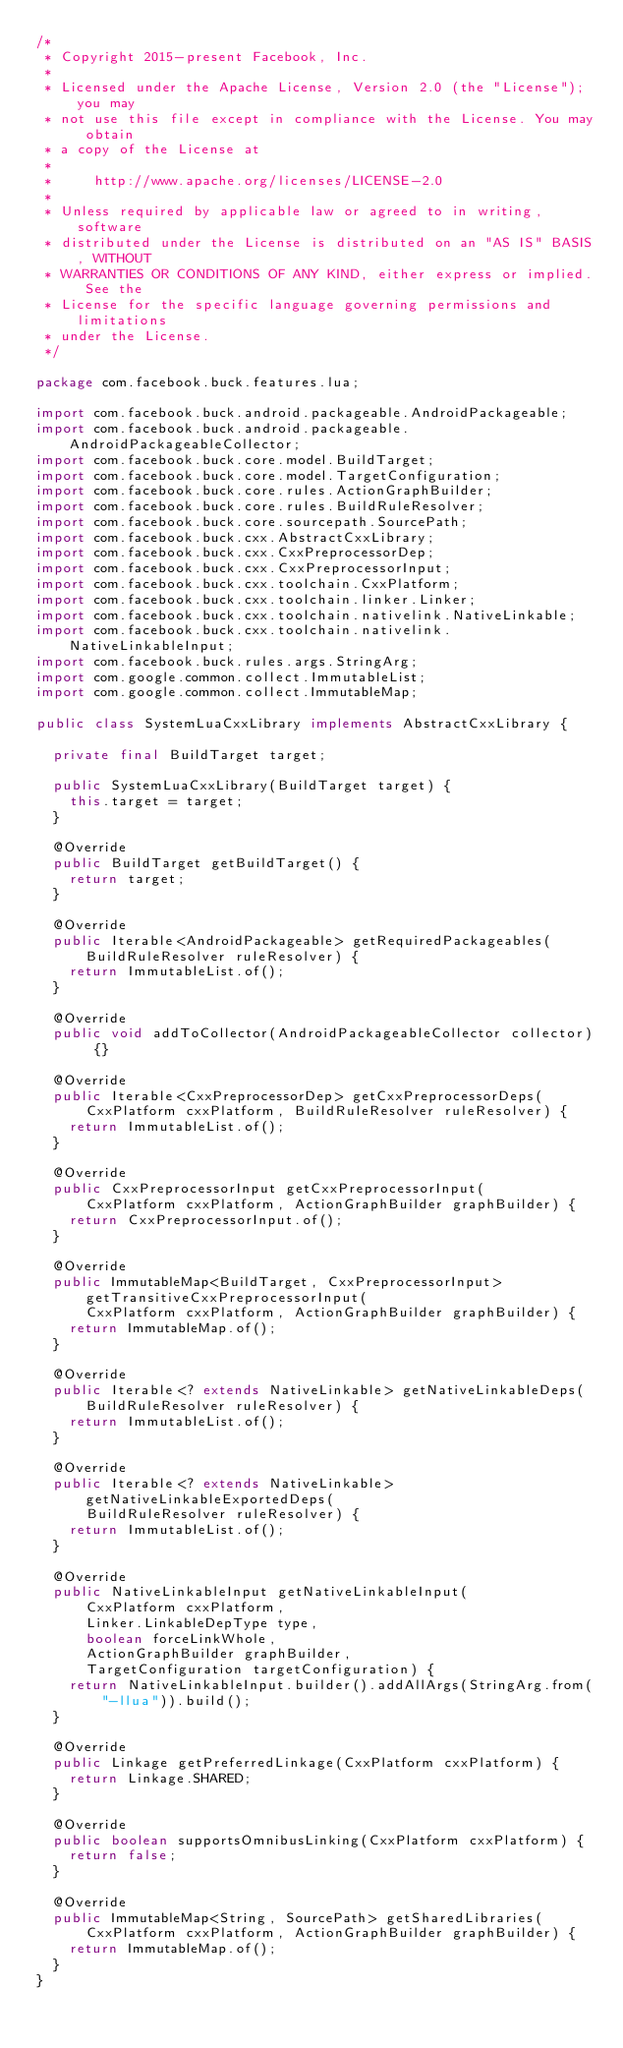<code> <loc_0><loc_0><loc_500><loc_500><_Java_>/*
 * Copyright 2015-present Facebook, Inc.
 *
 * Licensed under the Apache License, Version 2.0 (the "License"); you may
 * not use this file except in compliance with the License. You may obtain
 * a copy of the License at
 *
 *     http://www.apache.org/licenses/LICENSE-2.0
 *
 * Unless required by applicable law or agreed to in writing, software
 * distributed under the License is distributed on an "AS IS" BASIS, WITHOUT
 * WARRANTIES OR CONDITIONS OF ANY KIND, either express or implied. See the
 * License for the specific language governing permissions and limitations
 * under the License.
 */

package com.facebook.buck.features.lua;

import com.facebook.buck.android.packageable.AndroidPackageable;
import com.facebook.buck.android.packageable.AndroidPackageableCollector;
import com.facebook.buck.core.model.BuildTarget;
import com.facebook.buck.core.model.TargetConfiguration;
import com.facebook.buck.core.rules.ActionGraphBuilder;
import com.facebook.buck.core.rules.BuildRuleResolver;
import com.facebook.buck.core.sourcepath.SourcePath;
import com.facebook.buck.cxx.AbstractCxxLibrary;
import com.facebook.buck.cxx.CxxPreprocessorDep;
import com.facebook.buck.cxx.CxxPreprocessorInput;
import com.facebook.buck.cxx.toolchain.CxxPlatform;
import com.facebook.buck.cxx.toolchain.linker.Linker;
import com.facebook.buck.cxx.toolchain.nativelink.NativeLinkable;
import com.facebook.buck.cxx.toolchain.nativelink.NativeLinkableInput;
import com.facebook.buck.rules.args.StringArg;
import com.google.common.collect.ImmutableList;
import com.google.common.collect.ImmutableMap;

public class SystemLuaCxxLibrary implements AbstractCxxLibrary {

  private final BuildTarget target;

  public SystemLuaCxxLibrary(BuildTarget target) {
    this.target = target;
  }

  @Override
  public BuildTarget getBuildTarget() {
    return target;
  }

  @Override
  public Iterable<AndroidPackageable> getRequiredPackageables(BuildRuleResolver ruleResolver) {
    return ImmutableList.of();
  }

  @Override
  public void addToCollector(AndroidPackageableCollector collector) {}

  @Override
  public Iterable<CxxPreprocessorDep> getCxxPreprocessorDeps(
      CxxPlatform cxxPlatform, BuildRuleResolver ruleResolver) {
    return ImmutableList.of();
  }

  @Override
  public CxxPreprocessorInput getCxxPreprocessorInput(
      CxxPlatform cxxPlatform, ActionGraphBuilder graphBuilder) {
    return CxxPreprocessorInput.of();
  }

  @Override
  public ImmutableMap<BuildTarget, CxxPreprocessorInput> getTransitiveCxxPreprocessorInput(
      CxxPlatform cxxPlatform, ActionGraphBuilder graphBuilder) {
    return ImmutableMap.of();
  }

  @Override
  public Iterable<? extends NativeLinkable> getNativeLinkableDeps(BuildRuleResolver ruleResolver) {
    return ImmutableList.of();
  }

  @Override
  public Iterable<? extends NativeLinkable> getNativeLinkableExportedDeps(
      BuildRuleResolver ruleResolver) {
    return ImmutableList.of();
  }

  @Override
  public NativeLinkableInput getNativeLinkableInput(
      CxxPlatform cxxPlatform,
      Linker.LinkableDepType type,
      boolean forceLinkWhole,
      ActionGraphBuilder graphBuilder,
      TargetConfiguration targetConfiguration) {
    return NativeLinkableInput.builder().addAllArgs(StringArg.from("-llua")).build();
  }

  @Override
  public Linkage getPreferredLinkage(CxxPlatform cxxPlatform) {
    return Linkage.SHARED;
  }

  @Override
  public boolean supportsOmnibusLinking(CxxPlatform cxxPlatform) {
    return false;
  }

  @Override
  public ImmutableMap<String, SourcePath> getSharedLibraries(
      CxxPlatform cxxPlatform, ActionGraphBuilder graphBuilder) {
    return ImmutableMap.of();
  }
}
</code> 